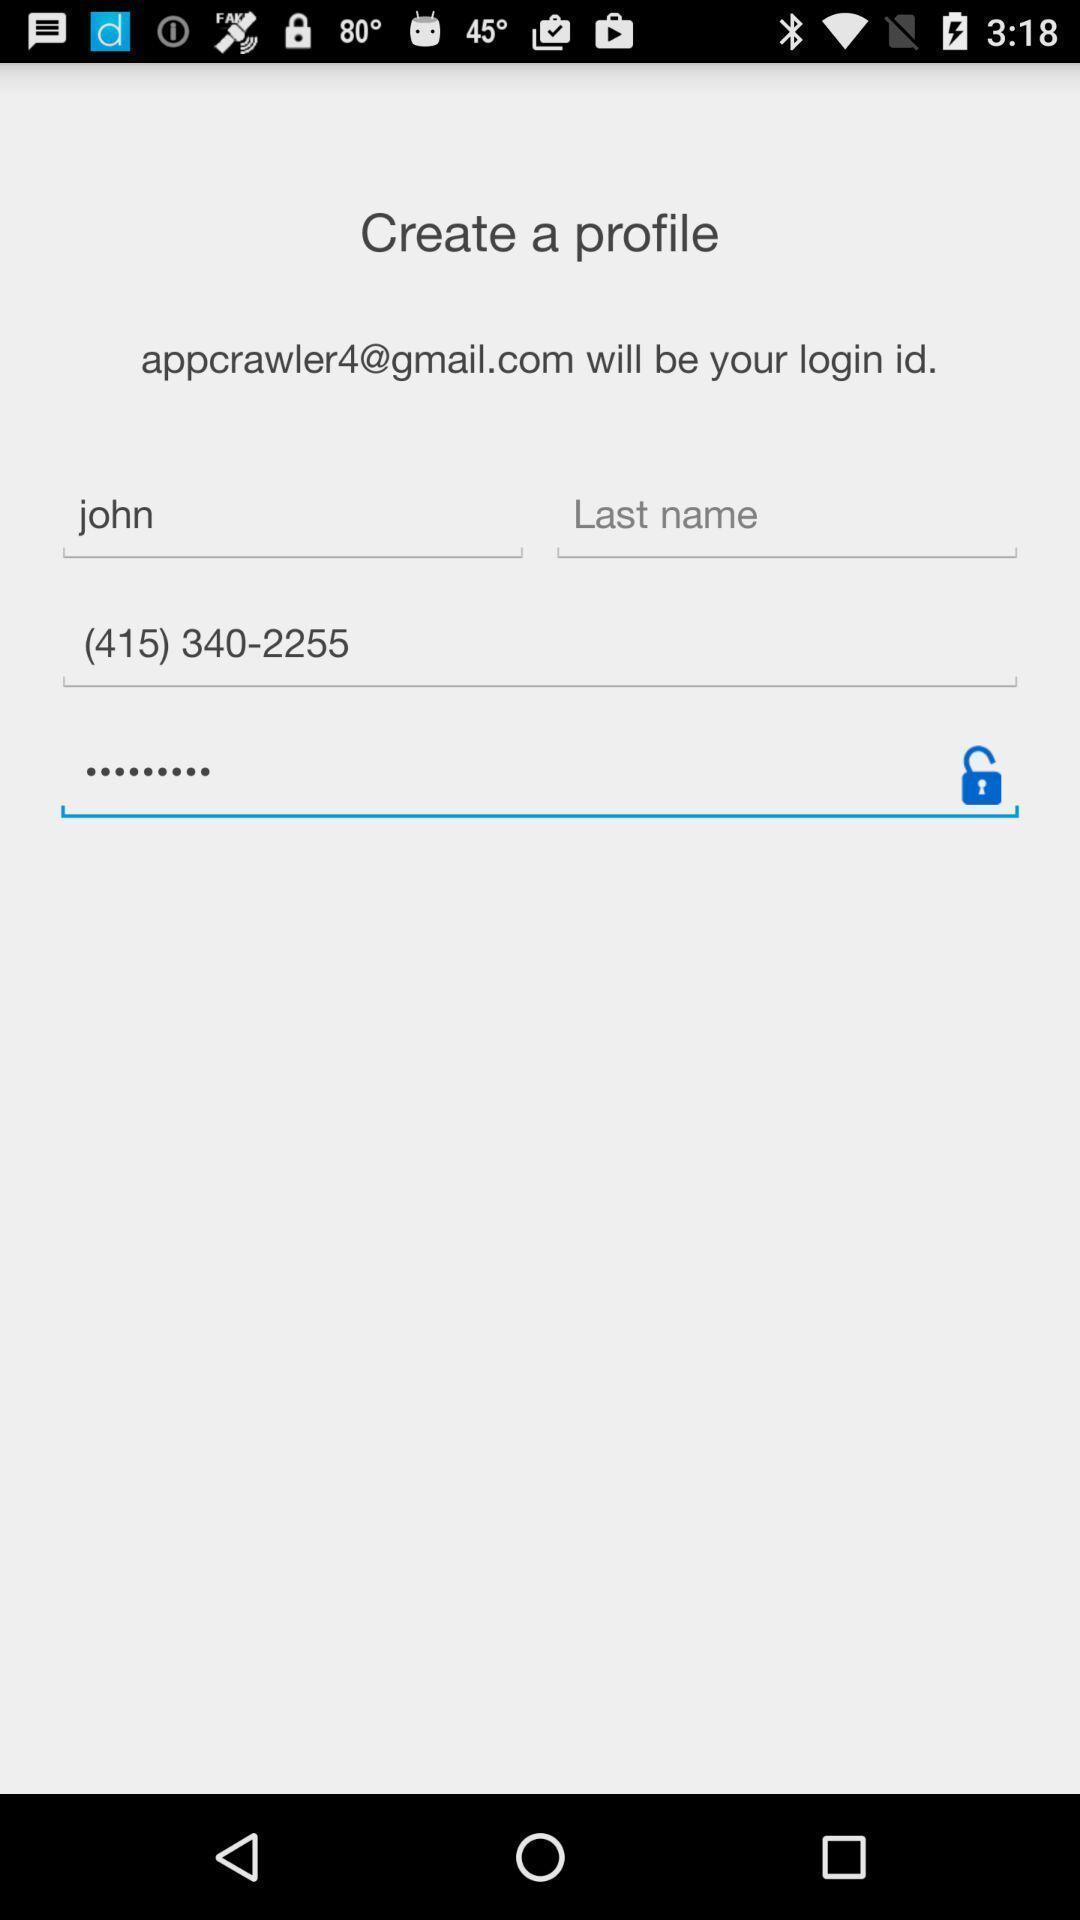Please provide a description for this image. Page displaying the details. 